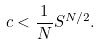<formula> <loc_0><loc_0><loc_500><loc_500>c < \frac { 1 } { N } S ^ { N / 2 } .</formula> 